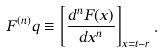<formula> <loc_0><loc_0><loc_500><loc_500>F ^ { ( n ) } q \equiv \left [ \frac { d ^ { n } F ( x ) } { d x ^ { n } } \right ] _ { x = t - r } .</formula> 